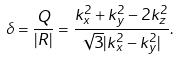Convert formula to latex. <formula><loc_0><loc_0><loc_500><loc_500>\delta = \frac { Q } { | R | } = \frac { k _ { x } ^ { 2 } + k _ { y } ^ { 2 } - 2 k _ { z } ^ { 2 } } { \sqrt { 3 } | k _ { x } ^ { 2 } - k _ { y } ^ { 2 } | } .</formula> 